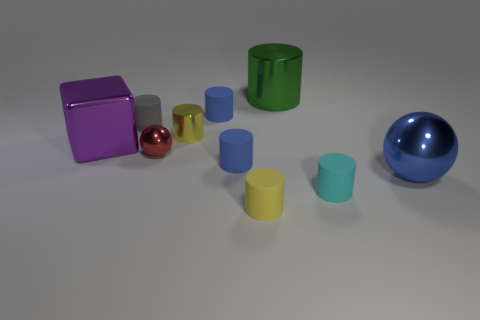Does the big thing that is on the left side of the yellow matte thing have the same material as the yellow cylinder that is on the right side of the small yellow metal cylinder?
Provide a succinct answer. No. There is a blue rubber cylinder that is in front of the tiny blue thing behind the red metallic ball; how big is it?
Your response must be concise. Small. There is another large thing that is the same shape as the gray matte thing; what is its material?
Offer a very short reply. Metal. There is a blue matte object behind the metal block; is its shape the same as the shiny thing that is left of the tiny red metallic thing?
Make the answer very short. No. Are there more cylinders than things?
Give a very brief answer. No. What size is the red object?
Make the answer very short. Small. How many other things are the same color as the big sphere?
Ensure brevity in your answer.  2. Are the ball on the left side of the big blue ball and the big green cylinder made of the same material?
Your answer should be very brief. Yes. Are there fewer big green shiny things that are in front of the cyan matte cylinder than tiny things that are behind the big purple metallic block?
Provide a succinct answer. Yes. How many other objects are there of the same material as the cyan cylinder?
Provide a succinct answer. 4. 